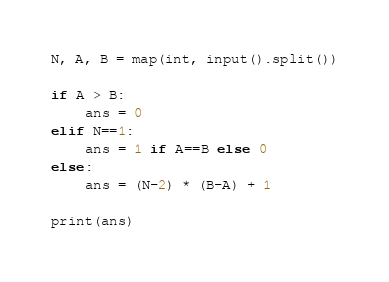Convert code to text. <code><loc_0><loc_0><loc_500><loc_500><_Python_>N, A, B = map(int, input().split())

if A > B:
    ans = 0
elif N==1:
    ans = 1 if A==B else 0
else:
    ans = (N-2) * (B-A) + 1

print(ans)</code> 